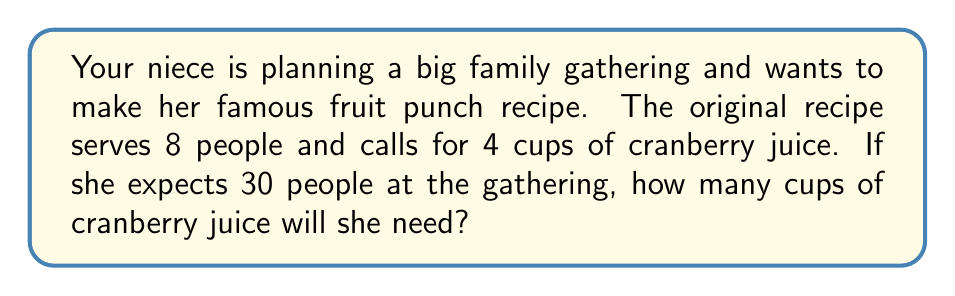Provide a solution to this math problem. Let's approach this step-by-step:

1) First, we need to determine the scale factor. This is the ratio of the new number of servings to the original number of servings.

   Scale factor = $\frac{\text{New servings}}{\text{Original servings}} = \frac{30}{8}$

2) We can simplify this fraction:
   
   $\frac{30}{8} = \frac{15}{4} = 3.75$

3) This means we need to multiply all ingredients in the original recipe by 3.75 to get the new amounts.

4) The original recipe calls for 4 cups of cranberry juice. So we multiply this by our scale factor:

   $4 \times 3.75 = 15$

Therefore, your niece will need 15 cups of cranberry juice for her gathering of 30 people.

This can be expressed mathematically as:

$$\text{New amount} = \text{Original amount} \times \frac{\text{New servings}}{\text{Original servings}}$$

$$\text{New amount} = 4 \times \frac{30}{8} = 4 \times 3.75 = 15$$
Answer: 15 cups of cranberry juice 